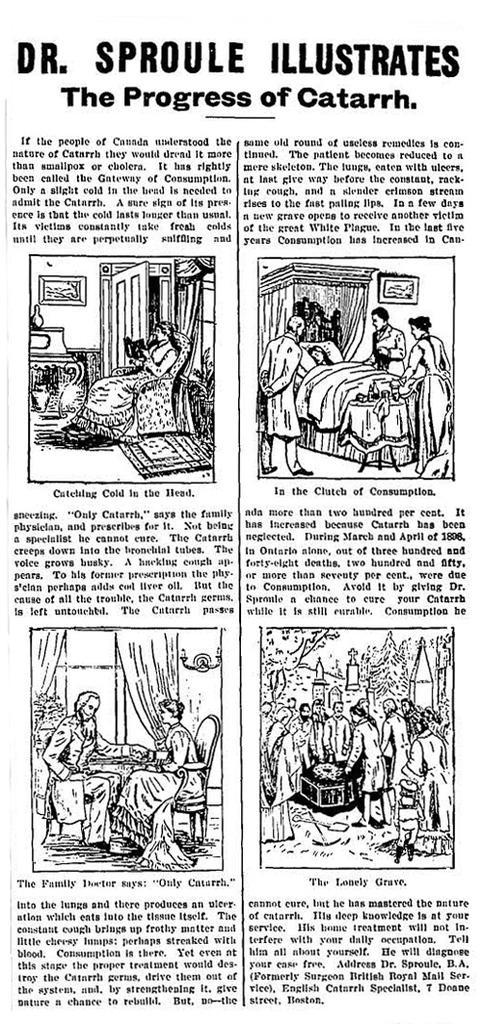How would you summarize this image in a sentence or two? In this image there is a paper with some text and art of a few persons. 